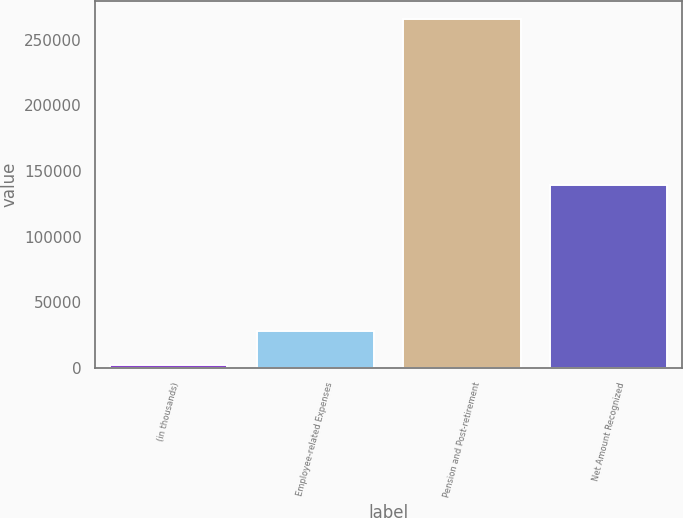<chart> <loc_0><loc_0><loc_500><loc_500><bar_chart><fcel>(in thousands)<fcel>Employee-related Expenses<fcel>Pension and Post-retirement<fcel>Net Amount Recognized<nl><fcel>2019<fcel>28413.3<fcel>265962<fcel>138889<nl></chart> 